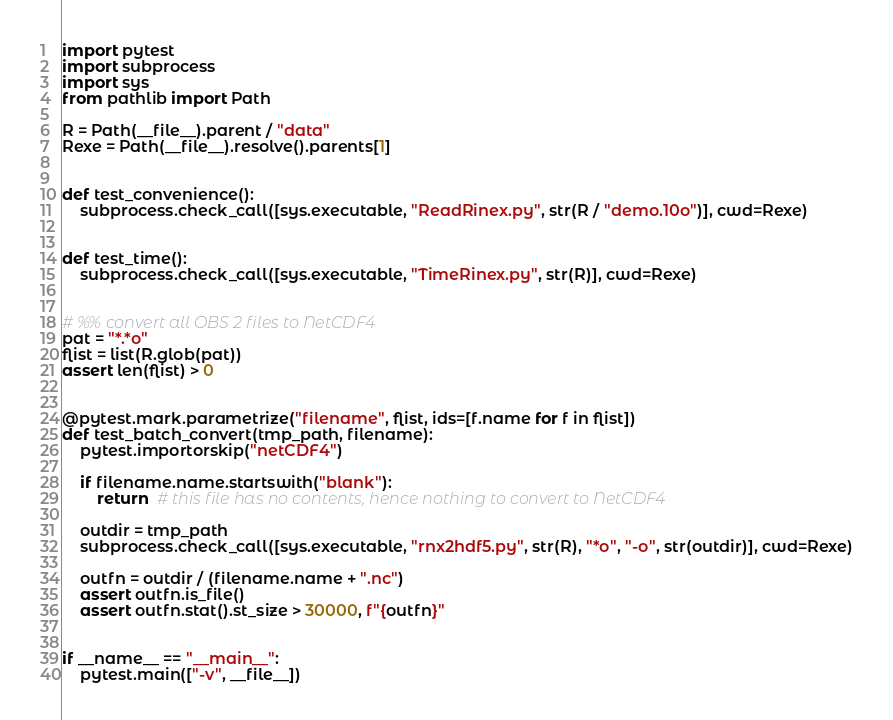Convert code to text. <code><loc_0><loc_0><loc_500><loc_500><_Python_>import pytest
import subprocess
import sys
from pathlib import Path

R = Path(__file__).parent / "data"
Rexe = Path(__file__).resolve().parents[1]


def test_convenience():
    subprocess.check_call([sys.executable, "ReadRinex.py", str(R / "demo.10o")], cwd=Rexe)


def test_time():
    subprocess.check_call([sys.executable, "TimeRinex.py", str(R)], cwd=Rexe)


# %% convert all OBS 2 files to NetCDF4
pat = "*.*o"
flist = list(R.glob(pat))
assert len(flist) > 0


@pytest.mark.parametrize("filename", flist, ids=[f.name for f in flist])
def test_batch_convert(tmp_path, filename):
    pytest.importorskip("netCDF4")

    if filename.name.startswith("blank"):
        return  # this file has no contents, hence nothing to convert to NetCDF4

    outdir = tmp_path
    subprocess.check_call([sys.executable, "rnx2hdf5.py", str(R), "*o", "-o", str(outdir)], cwd=Rexe)

    outfn = outdir / (filename.name + ".nc")
    assert outfn.is_file()
    assert outfn.stat().st_size > 30000, f"{outfn}"


if __name__ == "__main__":
    pytest.main(["-v", __file__])
</code> 